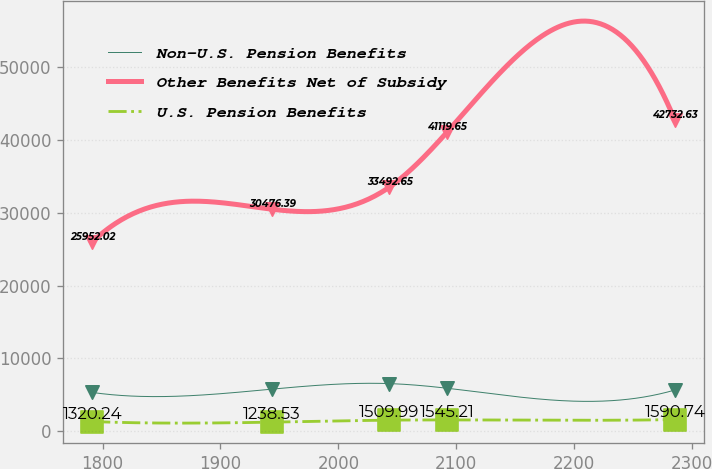<chart> <loc_0><loc_0><loc_500><loc_500><line_chart><ecel><fcel>Non-U.S. Pension Benefits<fcel>Other Benefits Net of Subsidy<fcel>U.S. Pension Benefits<nl><fcel>1791.12<fcel>5320.15<fcel>25952<fcel>1320.24<nl><fcel>1943.56<fcel>5767.8<fcel>30476.4<fcel>1238.53<nl><fcel>2043.1<fcel>6532.54<fcel>33492.7<fcel>1509.99<nl><fcel>2092.53<fcel>5889.04<fcel>41119.7<fcel>1545.21<nl><fcel>2285.39<fcel>5646.56<fcel>42732.6<fcel>1590.74<nl></chart> 